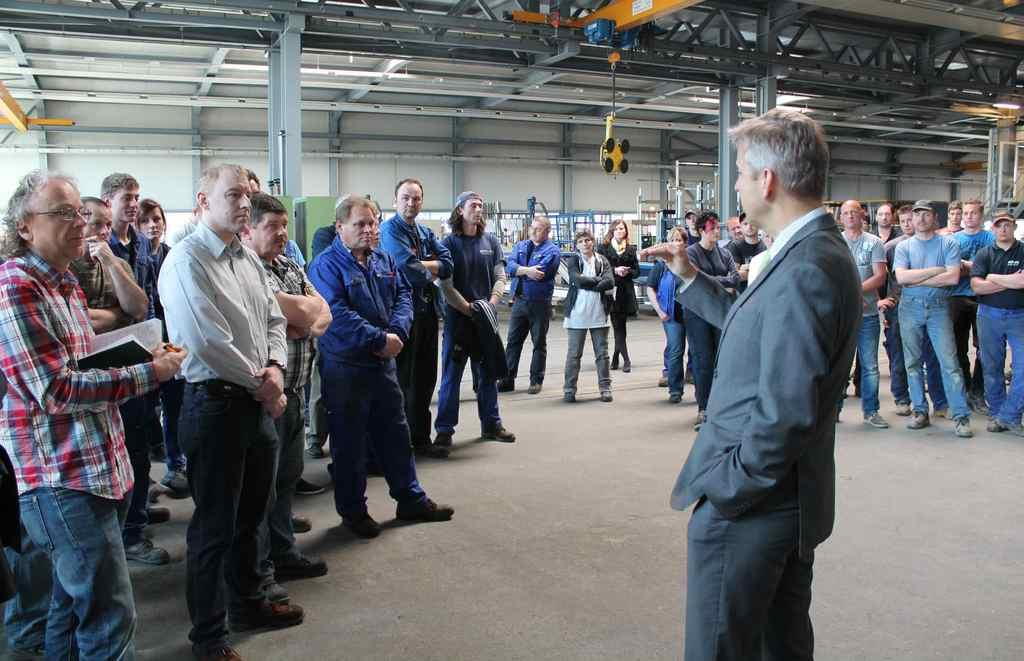What is happening in the image? There are people standing in the image. Can you describe the man in the image? There is a man standing in the image, and he is wearing a formal suit. What can be seen in the background of the image? There are mechanical machines visible in the background of the image. What type of art is the man creating in the image? There is no art or creation process visible in the image; the man is simply standing in a formal suit. 